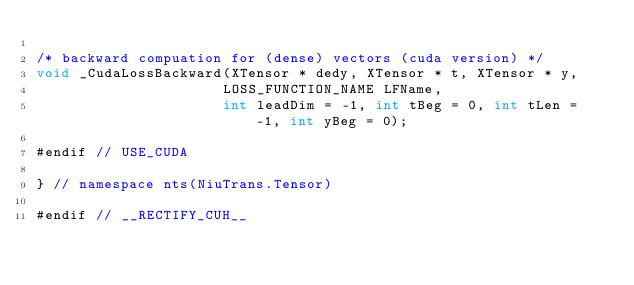<code> <loc_0><loc_0><loc_500><loc_500><_Cuda_>
/* backward compuation for (dense) vectors (cuda version) */
void _CudaLossBackward(XTensor * dedy, XTensor * t, XTensor * y, 
                      LOSS_FUNCTION_NAME LFName, 
                      int leadDim = -1, int tBeg = 0, int tLen = -1, int yBeg = 0);

#endif // USE_CUDA

} // namespace nts(NiuTrans.Tensor)

#endif // __RECTIFY_CUH__</code> 